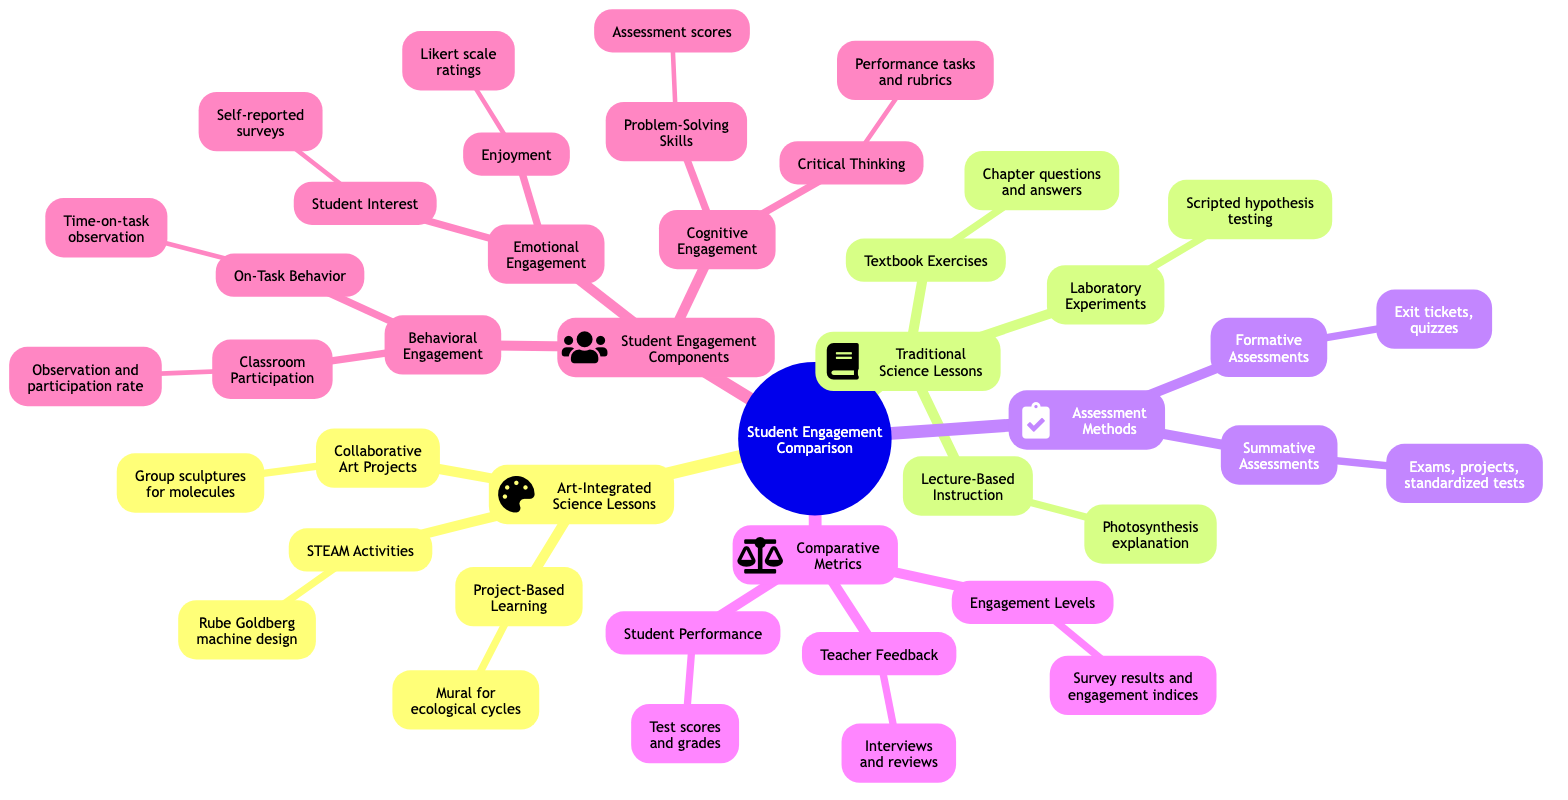What are the three categories of student engagement? The diagram lists three categories under "Student Engagement": Behavioral Engagement, Emotional Engagement, and Cognitive Engagement.
Answer: Behavioral Engagement, Emotional Engagement, Cognitive Engagement How many elements are in the "Art-Integrated Science Lessons"? The "Art-Integrated Science Lessons" category contains three elements: Project-Based Learning, Collaborative Art Projects, and STEAM Activities.
Answer: 3 What assessment method is used for formative assessments? Under "Assessment Methods," formative assessments include exit tickets and quizzes, which are examples of this assessment method.
Answer: Exit tickets, quizzes Which type of science lesson includes group sculptures representing molecular structures? The group sculptures representing molecular structures are an example of the "Collaborative Art Projects" under "Art-Integrated Science Lessons."
Answer: Collaborative Art Projects Which engagement type measures the observation and participation rate? The observation and participation rate is a measure of Classroom Participation, which falls under the Behavioral Engagement category.
Answer: Classroom Participation What are the comparative metrics used in the analysis? The comparative metrics include Student Performance, Engagement Levels, and Teacher Feedback.
Answer: Student Performance, Engagement Levels, Teacher Feedback Which sub-category of engagement involves self-reported surveys? Self-reported surveys are a measure for Student Interest, which is under the Emotional Engagement sub-category.
Answer: Student Interest How many examples of Traditional Science Lessons are provided? The Traditional Science Lessons category consists of three examples: Lecture-Based Instruction, Textbook Exercises, and Laboratory Experiments.
Answer: 3 Which category in the diagram focuses on critical thinking? Critical Thinking is listed under the Cognitive Engagement sub-category, which focuses on this aspect.
Answer: Cognitive Engagement 